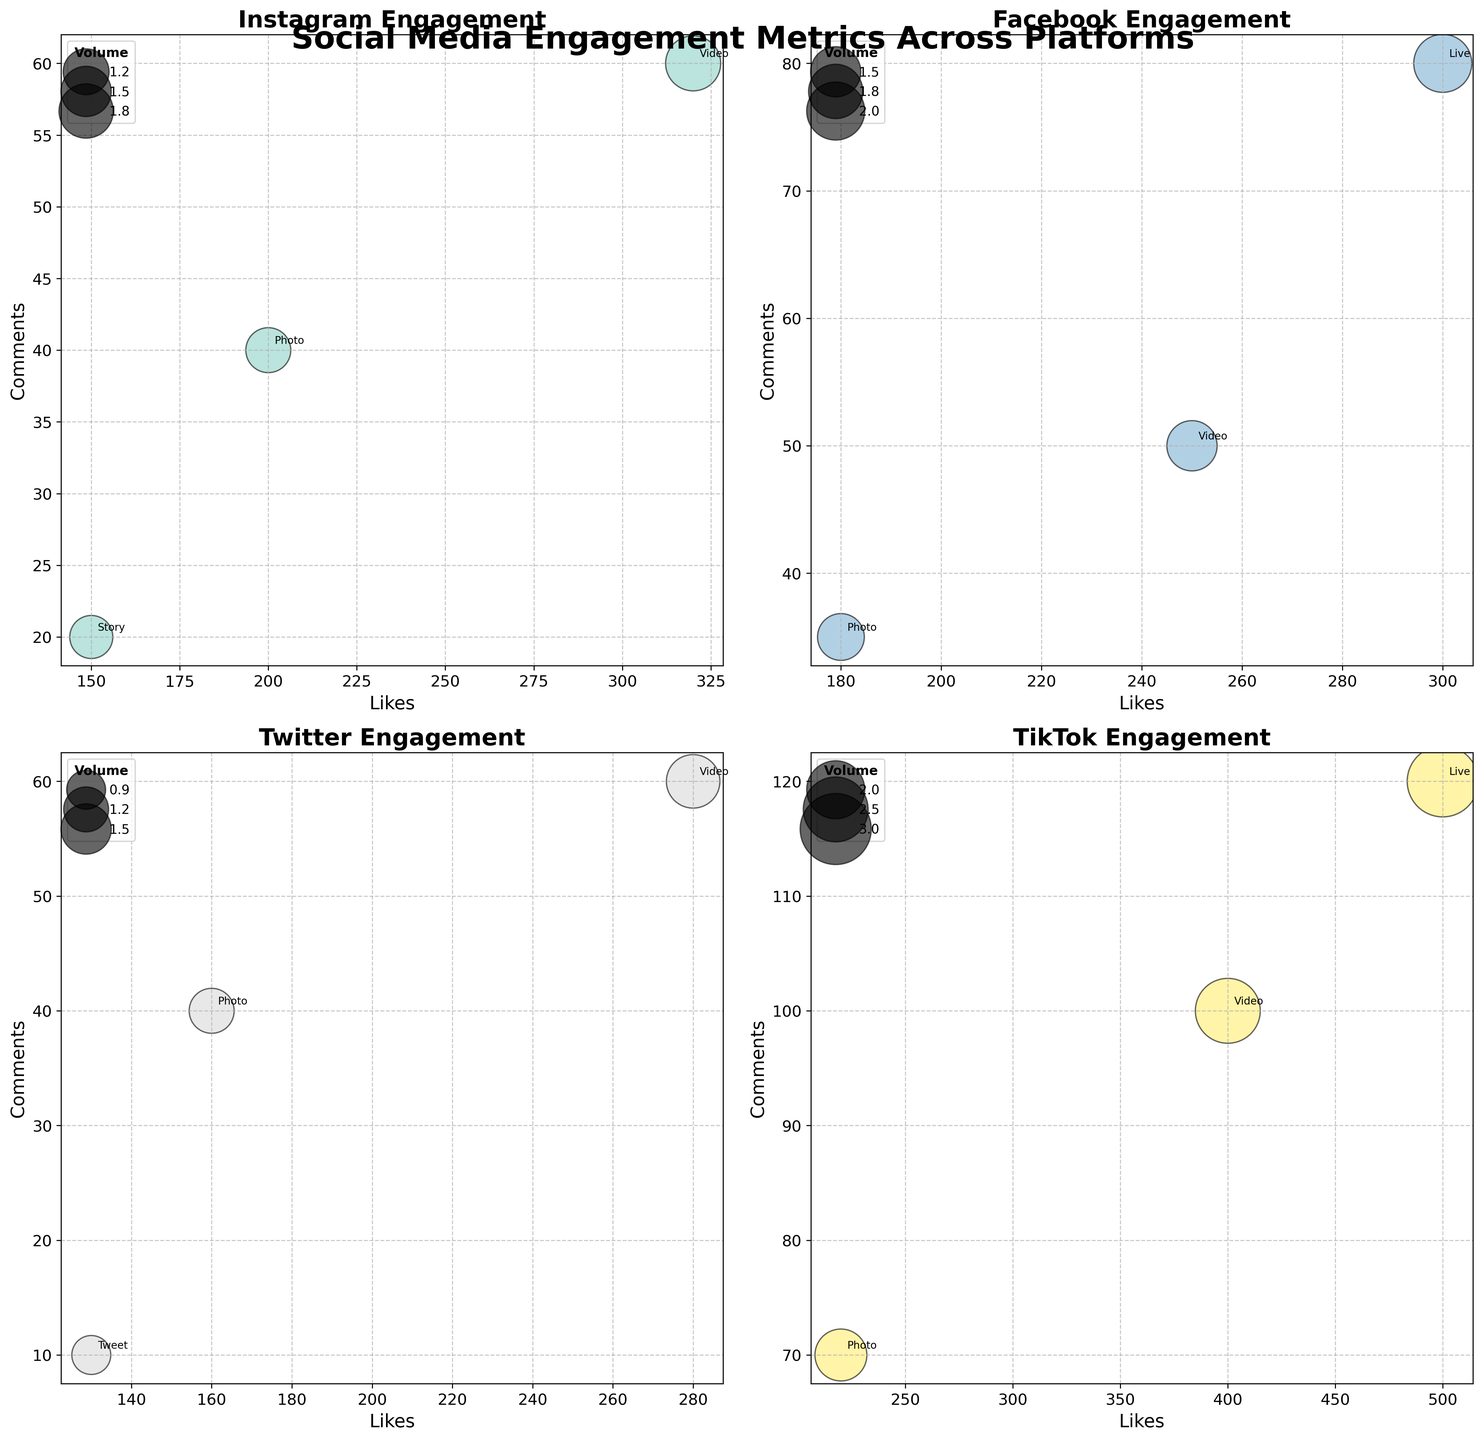What is the title of the figure? The title is typically found at the top of the figure and usually provides a summary of what the figure is about. In this case, the title is "Social Media Engagement Metrics Across Platforms".
Answer: Social Media Engagement Metrics Across Platforms Which platform has the highest volume for Live videos? To find the highest volume for Live videos, we look at the bubble sizes in the subplots. The largest bubble for Live videos is in the TikTok subplot, indicating TikTok has the highest volume.
Answer: TikTok During what time intervals are Instagram Photo posts made? To find the time intervals for Instagram Photo posts, look at the subplot for Instagram and identify the annotations with "Photo", then refer to the corresponding time interval values. The time interval for Instagram Photo posts is Evening.
Answer: Evening Which post type on Twitter has the lowest number of comments? In the Twitter subplot, look at the bubbles and their annotations. The bubble with the annotation "Tweet" has the lowest number of comments, positioned the lowest on the y-axis.
Answer: Tweet How many types of posts are represented in the Facebook subplot? To determine the number of different post types for Facebook, count the annotated post types in the Facebook subplot. The post types are Photo, Video, and Live.
Answer: Three What is the difference in the number of comments between the most commented Instagram post type and the most commented Facebook post type? Identify the highest y-axis values in the Instagram and Facebook subplots. Instagram's top commented post is a Video (60 comments), and Facebook's top commented post is a Live (80 comments). The difference is 80 - 60.
Answer: 20 Which time interval has the highest overall social media engagement based on bubble sizes? Compare the largest bubbles across all subplots to determine the time interval with the highest engagement. The largest bubble (based on volume) is for TikTok Live posts in the Evening.
Answer: Evening For the platform Instagram, what is the total number of likes across all post types? Sum up the likes for each post type in the Instagram subplot: Photo (200), Video (320), Story (150). Total likes = 200 + 320 + 150.
Answer: 670 Are there any platforms where the same post type appears in more than one time interval? Check each subplot to see if any post types are annotated at multiple time intervals. For example, check if 'Video' appears in multiple intervals for any platform.
Answer: No Which post type on TikTok has the highest number of likes? In the TikTok subplot, identify the highest x-axis value and the corresponding annotation. TikTok's post type with the highest likes is Live (500 likes).
Answer: Live 